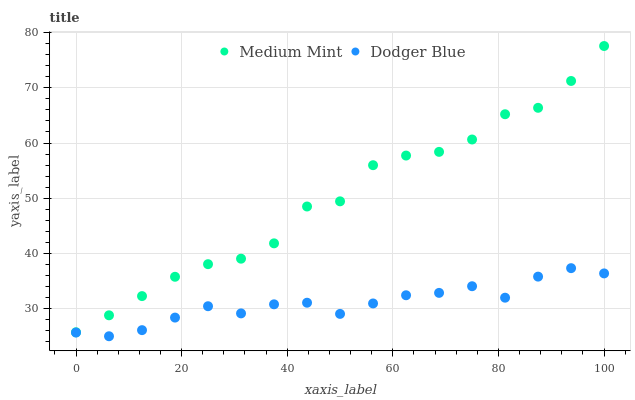Does Dodger Blue have the minimum area under the curve?
Answer yes or no. Yes. Does Medium Mint have the maximum area under the curve?
Answer yes or no. Yes. Does Dodger Blue have the maximum area under the curve?
Answer yes or no. No. Is Dodger Blue the smoothest?
Answer yes or no. Yes. Is Medium Mint the roughest?
Answer yes or no. Yes. Is Dodger Blue the roughest?
Answer yes or no. No. Does Dodger Blue have the lowest value?
Answer yes or no. Yes. Does Medium Mint have the highest value?
Answer yes or no. Yes. Does Dodger Blue have the highest value?
Answer yes or no. No. Is Dodger Blue less than Medium Mint?
Answer yes or no. Yes. Is Medium Mint greater than Dodger Blue?
Answer yes or no. Yes. Does Dodger Blue intersect Medium Mint?
Answer yes or no. No. 